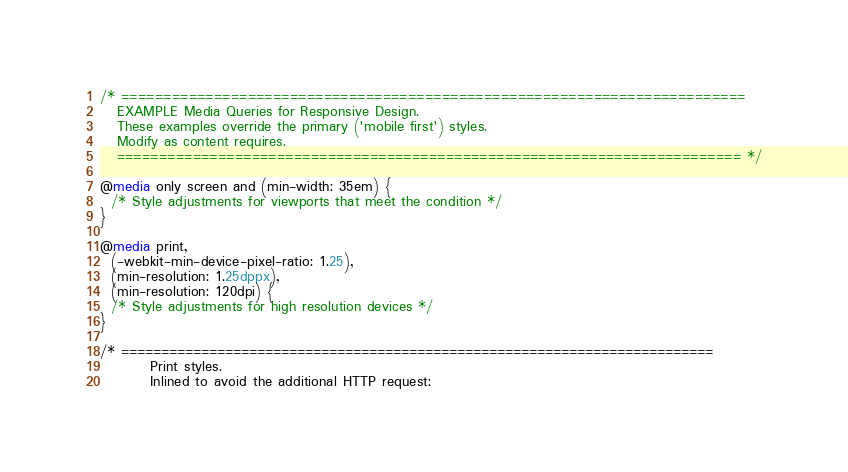Convert code to text. <code><loc_0><loc_0><loc_500><loc_500><_CSS_>/* ==========================================================================
   EXAMPLE Media Queries for Responsive Design.
   These examples override the primary ('mobile first') styles.
   Modify as content requires.
   ========================================================================== */

@media only screen and (min-width: 35em) {
  /* Style adjustments for viewports that meet the condition */
}

@media print,
  (-webkit-min-device-pixel-ratio: 1.25),
  (min-resolution: 1.25dppx),
  (min-resolution: 120dpi) {
  /* Style adjustments for high resolution devices */
}

/* ==========================================================================
         Print styles.
         Inlined to avoid the additional HTTP request:</code> 